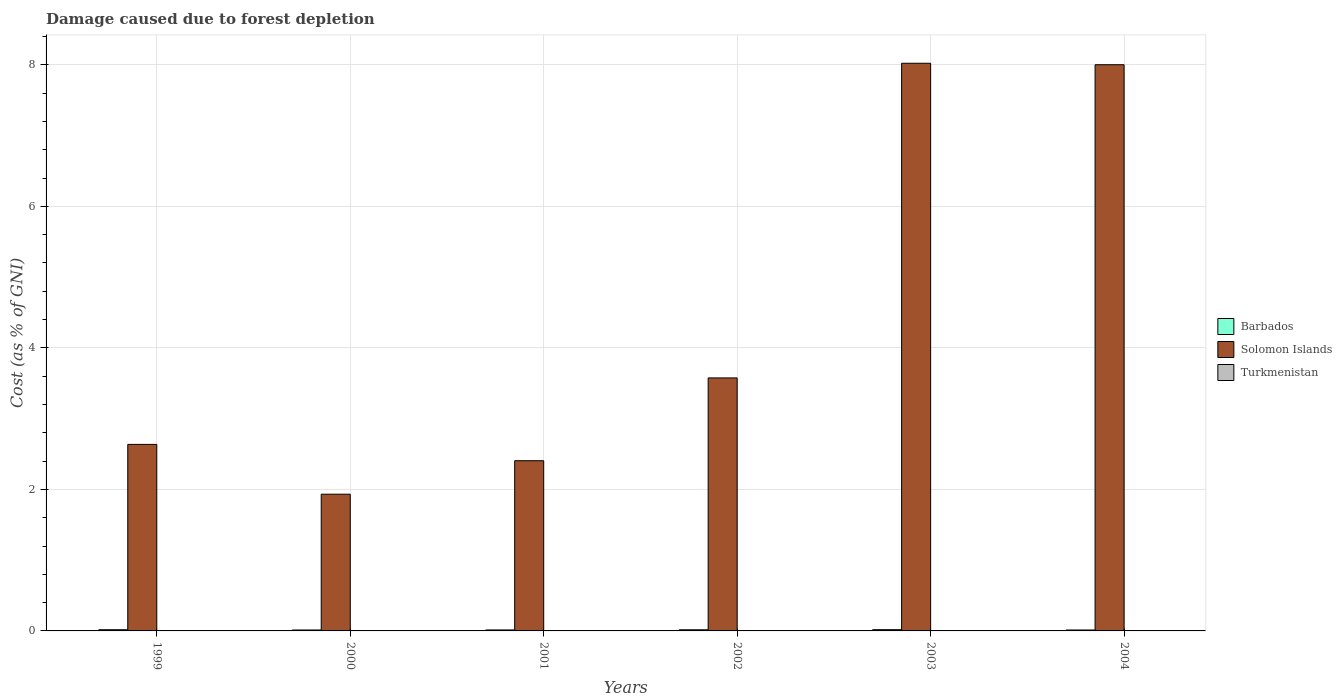Are the number of bars on each tick of the X-axis equal?
Your answer should be compact. Yes. How many bars are there on the 5th tick from the left?
Give a very brief answer. 3. How many bars are there on the 2nd tick from the right?
Your answer should be very brief. 3. In how many cases, is the number of bars for a given year not equal to the number of legend labels?
Provide a short and direct response. 0. What is the cost of damage caused due to forest depletion in Barbados in 2004?
Ensure brevity in your answer.  0.01. Across all years, what is the maximum cost of damage caused due to forest depletion in Barbados?
Your answer should be very brief. 0.02. Across all years, what is the minimum cost of damage caused due to forest depletion in Solomon Islands?
Keep it short and to the point. 1.93. In which year was the cost of damage caused due to forest depletion in Solomon Islands maximum?
Ensure brevity in your answer.  2003. What is the total cost of damage caused due to forest depletion in Solomon Islands in the graph?
Your response must be concise. 26.57. What is the difference between the cost of damage caused due to forest depletion in Turkmenistan in 2003 and that in 2004?
Give a very brief answer. 0. What is the difference between the cost of damage caused due to forest depletion in Solomon Islands in 2001 and the cost of damage caused due to forest depletion in Turkmenistan in 2004?
Your response must be concise. 2.4. What is the average cost of damage caused due to forest depletion in Solomon Islands per year?
Provide a succinct answer. 4.43. In the year 2002, what is the difference between the cost of damage caused due to forest depletion in Barbados and cost of damage caused due to forest depletion in Solomon Islands?
Your response must be concise. -3.56. In how many years, is the cost of damage caused due to forest depletion in Solomon Islands greater than 6.4 %?
Ensure brevity in your answer.  2. What is the ratio of the cost of damage caused due to forest depletion in Solomon Islands in 2001 to that in 2002?
Ensure brevity in your answer.  0.67. Is the difference between the cost of damage caused due to forest depletion in Barbados in 2000 and 2004 greater than the difference between the cost of damage caused due to forest depletion in Solomon Islands in 2000 and 2004?
Your answer should be very brief. Yes. What is the difference between the highest and the second highest cost of damage caused due to forest depletion in Turkmenistan?
Your response must be concise. 0. What is the difference between the highest and the lowest cost of damage caused due to forest depletion in Turkmenistan?
Ensure brevity in your answer.  0. What does the 2nd bar from the left in 2001 represents?
Offer a terse response. Solomon Islands. What does the 2nd bar from the right in 2002 represents?
Ensure brevity in your answer.  Solomon Islands. How many years are there in the graph?
Provide a short and direct response. 6. What is the difference between two consecutive major ticks on the Y-axis?
Give a very brief answer. 2. Are the values on the major ticks of Y-axis written in scientific E-notation?
Your answer should be compact. No. Does the graph contain grids?
Ensure brevity in your answer.  Yes. Where does the legend appear in the graph?
Your answer should be compact. Center right. How many legend labels are there?
Your response must be concise. 3. How are the legend labels stacked?
Provide a succinct answer. Vertical. What is the title of the graph?
Make the answer very short. Damage caused due to forest depletion. Does "Poland" appear as one of the legend labels in the graph?
Provide a short and direct response. No. What is the label or title of the Y-axis?
Your answer should be compact. Cost (as % of GNI). What is the Cost (as % of GNI) of Barbados in 1999?
Make the answer very short. 0.02. What is the Cost (as % of GNI) in Solomon Islands in 1999?
Provide a short and direct response. 2.64. What is the Cost (as % of GNI) of Turkmenistan in 1999?
Offer a very short reply. 0. What is the Cost (as % of GNI) of Barbados in 2000?
Provide a short and direct response. 0.01. What is the Cost (as % of GNI) in Solomon Islands in 2000?
Your response must be concise. 1.93. What is the Cost (as % of GNI) in Turkmenistan in 2000?
Your answer should be compact. 0. What is the Cost (as % of GNI) in Barbados in 2001?
Make the answer very short. 0.01. What is the Cost (as % of GNI) in Solomon Islands in 2001?
Offer a very short reply. 2.41. What is the Cost (as % of GNI) of Turkmenistan in 2001?
Provide a short and direct response. 0. What is the Cost (as % of GNI) in Barbados in 2002?
Provide a short and direct response. 0.02. What is the Cost (as % of GNI) of Solomon Islands in 2002?
Keep it short and to the point. 3.58. What is the Cost (as % of GNI) in Turkmenistan in 2002?
Ensure brevity in your answer.  0. What is the Cost (as % of GNI) of Barbados in 2003?
Your response must be concise. 0.02. What is the Cost (as % of GNI) of Solomon Islands in 2003?
Offer a terse response. 8.02. What is the Cost (as % of GNI) in Turkmenistan in 2003?
Offer a very short reply. 0. What is the Cost (as % of GNI) of Barbados in 2004?
Your answer should be compact. 0.01. What is the Cost (as % of GNI) of Solomon Islands in 2004?
Offer a very short reply. 8. What is the Cost (as % of GNI) in Turkmenistan in 2004?
Provide a short and direct response. 0. Across all years, what is the maximum Cost (as % of GNI) in Barbados?
Your response must be concise. 0.02. Across all years, what is the maximum Cost (as % of GNI) of Solomon Islands?
Keep it short and to the point. 8.02. Across all years, what is the maximum Cost (as % of GNI) of Turkmenistan?
Offer a terse response. 0. Across all years, what is the minimum Cost (as % of GNI) in Barbados?
Your response must be concise. 0.01. Across all years, what is the minimum Cost (as % of GNI) of Solomon Islands?
Give a very brief answer. 1.93. Across all years, what is the minimum Cost (as % of GNI) in Turkmenistan?
Provide a short and direct response. 0. What is the total Cost (as % of GNI) in Barbados in the graph?
Your answer should be compact. 0.09. What is the total Cost (as % of GNI) in Solomon Islands in the graph?
Offer a very short reply. 26.57. What is the total Cost (as % of GNI) in Turkmenistan in the graph?
Provide a short and direct response. 0.01. What is the difference between the Cost (as % of GNI) of Barbados in 1999 and that in 2000?
Your answer should be compact. 0. What is the difference between the Cost (as % of GNI) in Solomon Islands in 1999 and that in 2000?
Ensure brevity in your answer.  0.7. What is the difference between the Cost (as % of GNI) of Turkmenistan in 1999 and that in 2000?
Offer a very short reply. 0. What is the difference between the Cost (as % of GNI) of Barbados in 1999 and that in 2001?
Offer a very short reply. 0. What is the difference between the Cost (as % of GNI) in Solomon Islands in 1999 and that in 2001?
Your response must be concise. 0.23. What is the difference between the Cost (as % of GNI) of Turkmenistan in 1999 and that in 2001?
Make the answer very short. 0. What is the difference between the Cost (as % of GNI) of Barbados in 1999 and that in 2002?
Offer a very short reply. 0. What is the difference between the Cost (as % of GNI) of Solomon Islands in 1999 and that in 2002?
Keep it short and to the point. -0.94. What is the difference between the Cost (as % of GNI) of Turkmenistan in 1999 and that in 2002?
Make the answer very short. 0. What is the difference between the Cost (as % of GNI) in Barbados in 1999 and that in 2003?
Your answer should be compact. -0. What is the difference between the Cost (as % of GNI) of Solomon Islands in 1999 and that in 2003?
Your answer should be very brief. -5.39. What is the difference between the Cost (as % of GNI) in Turkmenistan in 1999 and that in 2003?
Keep it short and to the point. 0. What is the difference between the Cost (as % of GNI) in Barbados in 1999 and that in 2004?
Your response must be concise. 0. What is the difference between the Cost (as % of GNI) in Solomon Islands in 1999 and that in 2004?
Offer a very short reply. -5.37. What is the difference between the Cost (as % of GNI) in Turkmenistan in 1999 and that in 2004?
Your answer should be compact. 0. What is the difference between the Cost (as % of GNI) in Barbados in 2000 and that in 2001?
Offer a terse response. -0. What is the difference between the Cost (as % of GNI) in Solomon Islands in 2000 and that in 2001?
Offer a very short reply. -0.47. What is the difference between the Cost (as % of GNI) in Barbados in 2000 and that in 2002?
Provide a short and direct response. -0. What is the difference between the Cost (as % of GNI) in Solomon Islands in 2000 and that in 2002?
Offer a very short reply. -1.64. What is the difference between the Cost (as % of GNI) in Turkmenistan in 2000 and that in 2002?
Keep it short and to the point. 0. What is the difference between the Cost (as % of GNI) of Barbados in 2000 and that in 2003?
Make the answer very short. -0. What is the difference between the Cost (as % of GNI) in Solomon Islands in 2000 and that in 2003?
Offer a terse response. -6.09. What is the difference between the Cost (as % of GNI) in Turkmenistan in 2000 and that in 2003?
Ensure brevity in your answer.  0. What is the difference between the Cost (as % of GNI) of Barbados in 2000 and that in 2004?
Provide a succinct answer. 0. What is the difference between the Cost (as % of GNI) in Solomon Islands in 2000 and that in 2004?
Provide a short and direct response. -6.07. What is the difference between the Cost (as % of GNI) of Barbados in 2001 and that in 2002?
Keep it short and to the point. -0. What is the difference between the Cost (as % of GNI) of Solomon Islands in 2001 and that in 2002?
Ensure brevity in your answer.  -1.17. What is the difference between the Cost (as % of GNI) in Turkmenistan in 2001 and that in 2002?
Make the answer very short. -0. What is the difference between the Cost (as % of GNI) in Barbados in 2001 and that in 2003?
Offer a very short reply. -0. What is the difference between the Cost (as % of GNI) in Solomon Islands in 2001 and that in 2003?
Your response must be concise. -5.62. What is the difference between the Cost (as % of GNI) in Barbados in 2001 and that in 2004?
Give a very brief answer. 0. What is the difference between the Cost (as % of GNI) in Solomon Islands in 2001 and that in 2004?
Provide a short and direct response. -5.6. What is the difference between the Cost (as % of GNI) in Barbados in 2002 and that in 2003?
Your answer should be very brief. -0. What is the difference between the Cost (as % of GNI) in Solomon Islands in 2002 and that in 2003?
Offer a very short reply. -4.45. What is the difference between the Cost (as % of GNI) of Turkmenistan in 2002 and that in 2003?
Make the answer very short. 0. What is the difference between the Cost (as % of GNI) in Barbados in 2002 and that in 2004?
Your response must be concise. 0. What is the difference between the Cost (as % of GNI) of Solomon Islands in 2002 and that in 2004?
Offer a very short reply. -4.43. What is the difference between the Cost (as % of GNI) of Turkmenistan in 2002 and that in 2004?
Ensure brevity in your answer.  0. What is the difference between the Cost (as % of GNI) of Barbados in 2003 and that in 2004?
Offer a terse response. 0. What is the difference between the Cost (as % of GNI) in Solomon Islands in 2003 and that in 2004?
Provide a short and direct response. 0.02. What is the difference between the Cost (as % of GNI) of Turkmenistan in 2003 and that in 2004?
Provide a short and direct response. 0. What is the difference between the Cost (as % of GNI) in Barbados in 1999 and the Cost (as % of GNI) in Solomon Islands in 2000?
Ensure brevity in your answer.  -1.92. What is the difference between the Cost (as % of GNI) in Barbados in 1999 and the Cost (as % of GNI) in Turkmenistan in 2000?
Provide a succinct answer. 0.02. What is the difference between the Cost (as % of GNI) in Solomon Islands in 1999 and the Cost (as % of GNI) in Turkmenistan in 2000?
Your answer should be compact. 2.64. What is the difference between the Cost (as % of GNI) in Barbados in 1999 and the Cost (as % of GNI) in Solomon Islands in 2001?
Offer a very short reply. -2.39. What is the difference between the Cost (as % of GNI) of Barbados in 1999 and the Cost (as % of GNI) of Turkmenistan in 2001?
Your answer should be compact. 0.02. What is the difference between the Cost (as % of GNI) of Solomon Islands in 1999 and the Cost (as % of GNI) of Turkmenistan in 2001?
Make the answer very short. 2.64. What is the difference between the Cost (as % of GNI) of Barbados in 1999 and the Cost (as % of GNI) of Solomon Islands in 2002?
Your answer should be very brief. -3.56. What is the difference between the Cost (as % of GNI) in Barbados in 1999 and the Cost (as % of GNI) in Turkmenistan in 2002?
Offer a very short reply. 0.02. What is the difference between the Cost (as % of GNI) of Solomon Islands in 1999 and the Cost (as % of GNI) of Turkmenistan in 2002?
Give a very brief answer. 2.64. What is the difference between the Cost (as % of GNI) of Barbados in 1999 and the Cost (as % of GNI) of Solomon Islands in 2003?
Your answer should be very brief. -8.01. What is the difference between the Cost (as % of GNI) of Barbados in 1999 and the Cost (as % of GNI) of Turkmenistan in 2003?
Ensure brevity in your answer.  0.02. What is the difference between the Cost (as % of GNI) of Solomon Islands in 1999 and the Cost (as % of GNI) of Turkmenistan in 2003?
Offer a terse response. 2.64. What is the difference between the Cost (as % of GNI) in Barbados in 1999 and the Cost (as % of GNI) in Solomon Islands in 2004?
Provide a succinct answer. -7.98. What is the difference between the Cost (as % of GNI) of Barbados in 1999 and the Cost (as % of GNI) of Turkmenistan in 2004?
Your response must be concise. 0.02. What is the difference between the Cost (as % of GNI) in Solomon Islands in 1999 and the Cost (as % of GNI) in Turkmenistan in 2004?
Your answer should be very brief. 2.64. What is the difference between the Cost (as % of GNI) of Barbados in 2000 and the Cost (as % of GNI) of Solomon Islands in 2001?
Your response must be concise. -2.39. What is the difference between the Cost (as % of GNI) of Barbados in 2000 and the Cost (as % of GNI) of Turkmenistan in 2001?
Give a very brief answer. 0.01. What is the difference between the Cost (as % of GNI) of Solomon Islands in 2000 and the Cost (as % of GNI) of Turkmenistan in 2001?
Offer a terse response. 1.93. What is the difference between the Cost (as % of GNI) in Barbados in 2000 and the Cost (as % of GNI) in Solomon Islands in 2002?
Provide a short and direct response. -3.56. What is the difference between the Cost (as % of GNI) in Barbados in 2000 and the Cost (as % of GNI) in Turkmenistan in 2002?
Keep it short and to the point. 0.01. What is the difference between the Cost (as % of GNI) of Solomon Islands in 2000 and the Cost (as % of GNI) of Turkmenistan in 2002?
Your response must be concise. 1.93. What is the difference between the Cost (as % of GNI) of Barbados in 2000 and the Cost (as % of GNI) of Solomon Islands in 2003?
Ensure brevity in your answer.  -8.01. What is the difference between the Cost (as % of GNI) of Barbados in 2000 and the Cost (as % of GNI) of Turkmenistan in 2003?
Provide a short and direct response. 0.01. What is the difference between the Cost (as % of GNI) in Solomon Islands in 2000 and the Cost (as % of GNI) in Turkmenistan in 2003?
Keep it short and to the point. 1.93. What is the difference between the Cost (as % of GNI) of Barbados in 2000 and the Cost (as % of GNI) of Solomon Islands in 2004?
Your answer should be compact. -7.99. What is the difference between the Cost (as % of GNI) of Barbados in 2000 and the Cost (as % of GNI) of Turkmenistan in 2004?
Ensure brevity in your answer.  0.01. What is the difference between the Cost (as % of GNI) in Solomon Islands in 2000 and the Cost (as % of GNI) in Turkmenistan in 2004?
Keep it short and to the point. 1.93. What is the difference between the Cost (as % of GNI) of Barbados in 2001 and the Cost (as % of GNI) of Solomon Islands in 2002?
Provide a short and direct response. -3.56. What is the difference between the Cost (as % of GNI) in Barbados in 2001 and the Cost (as % of GNI) in Turkmenistan in 2002?
Make the answer very short. 0.01. What is the difference between the Cost (as % of GNI) in Solomon Islands in 2001 and the Cost (as % of GNI) in Turkmenistan in 2002?
Keep it short and to the point. 2.4. What is the difference between the Cost (as % of GNI) of Barbados in 2001 and the Cost (as % of GNI) of Solomon Islands in 2003?
Provide a short and direct response. -8.01. What is the difference between the Cost (as % of GNI) in Barbados in 2001 and the Cost (as % of GNI) in Turkmenistan in 2003?
Give a very brief answer. 0.01. What is the difference between the Cost (as % of GNI) of Solomon Islands in 2001 and the Cost (as % of GNI) of Turkmenistan in 2003?
Offer a terse response. 2.4. What is the difference between the Cost (as % of GNI) of Barbados in 2001 and the Cost (as % of GNI) of Solomon Islands in 2004?
Make the answer very short. -7.99. What is the difference between the Cost (as % of GNI) in Barbados in 2001 and the Cost (as % of GNI) in Turkmenistan in 2004?
Your answer should be compact. 0.01. What is the difference between the Cost (as % of GNI) in Solomon Islands in 2001 and the Cost (as % of GNI) in Turkmenistan in 2004?
Your response must be concise. 2.4. What is the difference between the Cost (as % of GNI) in Barbados in 2002 and the Cost (as % of GNI) in Solomon Islands in 2003?
Make the answer very short. -8.01. What is the difference between the Cost (as % of GNI) of Barbados in 2002 and the Cost (as % of GNI) of Turkmenistan in 2003?
Offer a terse response. 0.02. What is the difference between the Cost (as % of GNI) of Solomon Islands in 2002 and the Cost (as % of GNI) of Turkmenistan in 2003?
Make the answer very short. 3.57. What is the difference between the Cost (as % of GNI) in Barbados in 2002 and the Cost (as % of GNI) in Solomon Islands in 2004?
Your answer should be very brief. -7.99. What is the difference between the Cost (as % of GNI) of Barbados in 2002 and the Cost (as % of GNI) of Turkmenistan in 2004?
Make the answer very short. 0.02. What is the difference between the Cost (as % of GNI) of Solomon Islands in 2002 and the Cost (as % of GNI) of Turkmenistan in 2004?
Your answer should be very brief. 3.58. What is the difference between the Cost (as % of GNI) in Barbados in 2003 and the Cost (as % of GNI) in Solomon Islands in 2004?
Your response must be concise. -7.98. What is the difference between the Cost (as % of GNI) of Barbados in 2003 and the Cost (as % of GNI) of Turkmenistan in 2004?
Provide a succinct answer. 0.02. What is the difference between the Cost (as % of GNI) of Solomon Islands in 2003 and the Cost (as % of GNI) of Turkmenistan in 2004?
Offer a very short reply. 8.02. What is the average Cost (as % of GNI) of Barbados per year?
Offer a very short reply. 0.02. What is the average Cost (as % of GNI) in Solomon Islands per year?
Make the answer very short. 4.43. What is the average Cost (as % of GNI) of Turkmenistan per year?
Offer a terse response. 0. In the year 1999, what is the difference between the Cost (as % of GNI) of Barbados and Cost (as % of GNI) of Solomon Islands?
Give a very brief answer. -2.62. In the year 1999, what is the difference between the Cost (as % of GNI) of Barbados and Cost (as % of GNI) of Turkmenistan?
Offer a very short reply. 0.02. In the year 1999, what is the difference between the Cost (as % of GNI) of Solomon Islands and Cost (as % of GNI) of Turkmenistan?
Give a very brief answer. 2.63. In the year 2000, what is the difference between the Cost (as % of GNI) of Barbados and Cost (as % of GNI) of Solomon Islands?
Your answer should be compact. -1.92. In the year 2000, what is the difference between the Cost (as % of GNI) of Barbados and Cost (as % of GNI) of Turkmenistan?
Make the answer very short. 0.01. In the year 2000, what is the difference between the Cost (as % of GNI) in Solomon Islands and Cost (as % of GNI) in Turkmenistan?
Your answer should be compact. 1.93. In the year 2001, what is the difference between the Cost (as % of GNI) of Barbados and Cost (as % of GNI) of Solomon Islands?
Provide a succinct answer. -2.39. In the year 2001, what is the difference between the Cost (as % of GNI) of Barbados and Cost (as % of GNI) of Turkmenistan?
Keep it short and to the point. 0.01. In the year 2001, what is the difference between the Cost (as % of GNI) of Solomon Islands and Cost (as % of GNI) of Turkmenistan?
Your answer should be very brief. 2.4. In the year 2002, what is the difference between the Cost (as % of GNI) in Barbados and Cost (as % of GNI) in Solomon Islands?
Give a very brief answer. -3.56. In the year 2002, what is the difference between the Cost (as % of GNI) in Barbados and Cost (as % of GNI) in Turkmenistan?
Make the answer very short. 0.02. In the year 2002, what is the difference between the Cost (as % of GNI) in Solomon Islands and Cost (as % of GNI) in Turkmenistan?
Your answer should be compact. 3.57. In the year 2003, what is the difference between the Cost (as % of GNI) of Barbados and Cost (as % of GNI) of Solomon Islands?
Offer a terse response. -8. In the year 2003, what is the difference between the Cost (as % of GNI) of Barbados and Cost (as % of GNI) of Turkmenistan?
Keep it short and to the point. 0.02. In the year 2003, what is the difference between the Cost (as % of GNI) in Solomon Islands and Cost (as % of GNI) in Turkmenistan?
Offer a very short reply. 8.02. In the year 2004, what is the difference between the Cost (as % of GNI) of Barbados and Cost (as % of GNI) of Solomon Islands?
Make the answer very short. -7.99. In the year 2004, what is the difference between the Cost (as % of GNI) of Barbados and Cost (as % of GNI) of Turkmenistan?
Make the answer very short. 0.01. In the year 2004, what is the difference between the Cost (as % of GNI) of Solomon Islands and Cost (as % of GNI) of Turkmenistan?
Provide a succinct answer. 8. What is the ratio of the Cost (as % of GNI) of Barbados in 1999 to that in 2000?
Make the answer very short. 1.3. What is the ratio of the Cost (as % of GNI) of Solomon Islands in 1999 to that in 2000?
Keep it short and to the point. 1.36. What is the ratio of the Cost (as % of GNI) of Turkmenistan in 1999 to that in 2000?
Give a very brief answer. 1.5. What is the ratio of the Cost (as % of GNI) of Barbados in 1999 to that in 2001?
Make the answer very short. 1.24. What is the ratio of the Cost (as % of GNI) of Solomon Islands in 1999 to that in 2001?
Your response must be concise. 1.1. What is the ratio of the Cost (as % of GNI) in Turkmenistan in 1999 to that in 2001?
Your answer should be very brief. 1.75. What is the ratio of the Cost (as % of GNI) of Barbados in 1999 to that in 2002?
Your answer should be very brief. 1.06. What is the ratio of the Cost (as % of GNI) in Solomon Islands in 1999 to that in 2002?
Ensure brevity in your answer.  0.74. What is the ratio of the Cost (as % of GNI) of Turkmenistan in 1999 to that in 2002?
Provide a succinct answer. 1.67. What is the ratio of the Cost (as % of GNI) of Barbados in 1999 to that in 2003?
Make the answer very short. 0.96. What is the ratio of the Cost (as % of GNI) in Solomon Islands in 1999 to that in 2003?
Provide a succinct answer. 0.33. What is the ratio of the Cost (as % of GNI) in Turkmenistan in 1999 to that in 2003?
Make the answer very short. 1.71. What is the ratio of the Cost (as % of GNI) of Barbados in 1999 to that in 2004?
Offer a terse response. 1.31. What is the ratio of the Cost (as % of GNI) in Solomon Islands in 1999 to that in 2004?
Give a very brief answer. 0.33. What is the ratio of the Cost (as % of GNI) of Turkmenistan in 1999 to that in 2004?
Offer a very short reply. 2.22. What is the ratio of the Cost (as % of GNI) in Barbados in 2000 to that in 2001?
Offer a terse response. 0.95. What is the ratio of the Cost (as % of GNI) in Solomon Islands in 2000 to that in 2001?
Keep it short and to the point. 0.8. What is the ratio of the Cost (as % of GNI) in Turkmenistan in 2000 to that in 2001?
Provide a short and direct response. 1.17. What is the ratio of the Cost (as % of GNI) of Barbados in 2000 to that in 2002?
Keep it short and to the point. 0.81. What is the ratio of the Cost (as % of GNI) of Solomon Islands in 2000 to that in 2002?
Provide a short and direct response. 0.54. What is the ratio of the Cost (as % of GNI) of Turkmenistan in 2000 to that in 2002?
Offer a terse response. 1.12. What is the ratio of the Cost (as % of GNI) of Barbados in 2000 to that in 2003?
Make the answer very short. 0.74. What is the ratio of the Cost (as % of GNI) of Solomon Islands in 2000 to that in 2003?
Make the answer very short. 0.24. What is the ratio of the Cost (as % of GNI) in Turkmenistan in 2000 to that in 2003?
Your response must be concise. 1.14. What is the ratio of the Cost (as % of GNI) in Barbados in 2000 to that in 2004?
Make the answer very short. 1.01. What is the ratio of the Cost (as % of GNI) in Solomon Islands in 2000 to that in 2004?
Ensure brevity in your answer.  0.24. What is the ratio of the Cost (as % of GNI) in Turkmenistan in 2000 to that in 2004?
Your answer should be very brief. 1.48. What is the ratio of the Cost (as % of GNI) of Barbados in 2001 to that in 2002?
Give a very brief answer. 0.85. What is the ratio of the Cost (as % of GNI) in Solomon Islands in 2001 to that in 2002?
Offer a terse response. 0.67. What is the ratio of the Cost (as % of GNI) in Turkmenistan in 2001 to that in 2002?
Give a very brief answer. 0.95. What is the ratio of the Cost (as % of GNI) of Barbados in 2001 to that in 2003?
Your response must be concise. 0.78. What is the ratio of the Cost (as % of GNI) in Solomon Islands in 2001 to that in 2003?
Ensure brevity in your answer.  0.3. What is the ratio of the Cost (as % of GNI) of Turkmenistan in 2001 to that in 2003?
Your answer should be compact. 0.98. What is the ratio of the Cost (as % of GNI) of Barbados in 2001 to that in 2004?
Make the answer very short. 1.06. What is the ratio of the Cost (as % of GNI) of Solomon Islands in 2001 to that in 2004?
Your response must be concise. 0.3. What is the ratio of the Cost (as % of GNI) of Turkmenistan in 2001 to that in 2004?
Give a very brief answer. 1.27. What is the ratio of the Cost (as % of GNI) in Barbados in 2002 to that in 2003?
Provide a short and direct response. 0.91. What is the ratio of the Cost (as % of GNI) of Solomon Islands in 2002 to that in 2003?
Keep it short and to the point. 0.45. What is the ratio of the Cost (as % of GNI) of Turkmenistan in 2002 to that in 2003?
Provide a short and direct response. 1.02. What is the ratio of the Cost (as % of GNI) in Barbados in 2002 to that in 2004?
Offer a very short reply. 1.24. What is the ratio of the Cost (as % of GNI) of Solomon Islands in 2002 to that in 2004?
Give a very brief answer. 0.45. What is the ratio of the Cost (as % of GNI) of Turkmenistan in 2002 to that in 2004?
Keep it short and to the point. 1.33. What is the ratio of the Cost (as % of GNI) of Barbados in 2003 to that in 2004?
Offer a terse response. 1.36. What is the ratio of the Cost (as % of GNI) in Solomon Islands in 2003 to that in 2004?
Keep it short and to the point. 1. What is the ratio of the Cost (as % of GNI) in Turkmenistan in 2003 to that in 2004?
Offer a terse response. 1.3. What is the difference between the highest and the second highest Cost (as % of GNI) in Barbados?
Keep it short and to the point. 0. What is the difference between the highest and the second highest Cost (as % of GNI) of Solomon Islands?
Make the answer very short. 0.02. What is the difference between the highest and the lowest Cost (as % of GNI) in Barbados?
Provide a succinct answer. 0. What is the difference between the highest and the lowest Cost (as % of GNI) in Solomon Islands?
Offer a very short reply. 6.09. What is the difference between the highest and the lowest Cost (as % of GNI) of Turkmenistan?
Keep it short and to the point. 0. 